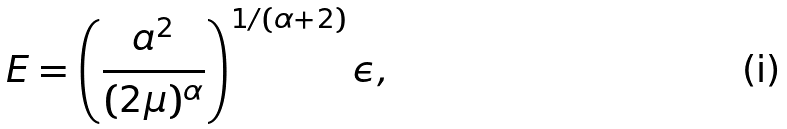Convert formula to latex. <formula><loc_0><loc_0><loc_500><loc_500>E = \left ( \frac { a ^ { 2 } } { ( 2 \mu ) ^ { \alpha } } \right ) ^ { 1 / ( \alpha + 2 ) } \epsilon ,</formula> 